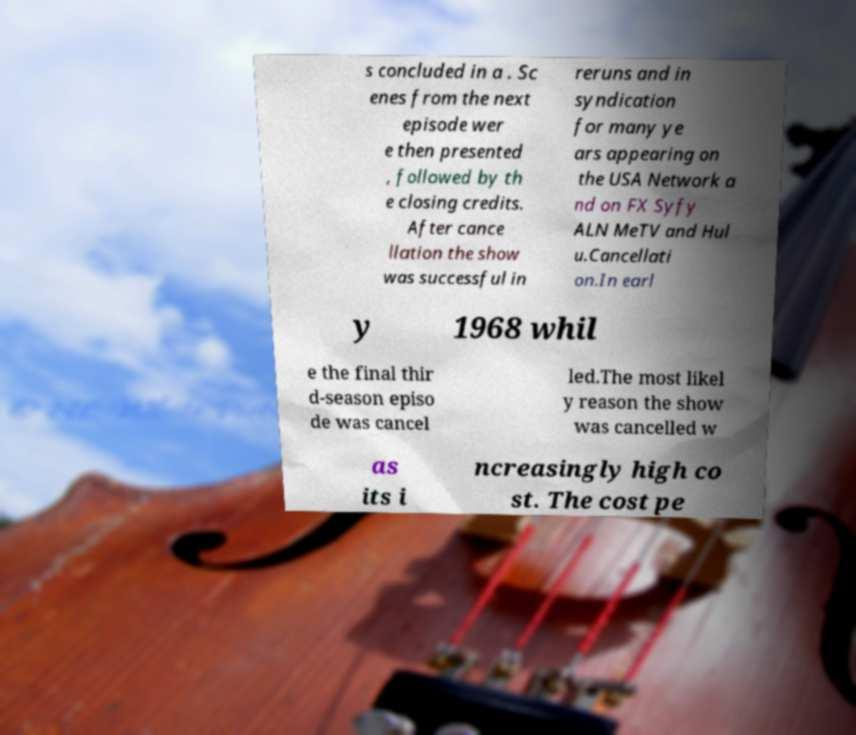Please identify and transcribe the text found in this image. s concluded in a . Sc enes from the next episode wer e then presented , followed by th e closing credits. After cance llation the show was successful in reruns and in syndication for many ye ars appearing on the USA Network a nd on FX Syfy ALN MeTV and Hul u.Cancellati on.In earl y 1968 whil e the final thir d-season episo de was cancel led.The most likel y reason the show was cancelled w as its i ncreasingly high co st. The cost pe 